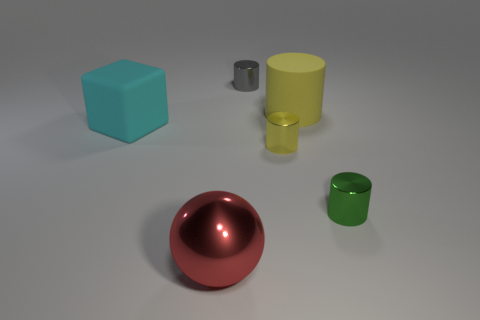What is the material of the other cylinder that is the same color as the big cylinder?
Provide a short and direct response. Metal. There is a big thing in front of the rubber thing in front of the big yellow cylinder; is there a big shiny thing that is behind it?
Ensure brevity in your answer.  No. What number of other things are there of the same material as the big yellow thing
Provide a short and direct response. 1. How many brown matte cubes are there?
Offer a terse response. 0. How many things are either large cyan matte objects or cylinders that are in front of the large matte cylinder?
Your answer should be compact. 3. Are there any other things that have the same shape as the large red metal thing?
Offer a very short reply. No. There is a thing that is left of the red shiny object; does it have the same size as the yellow shiny thing?
Give a very brief answer. No. How many matte things are either yellow balls or cubes?
Make the answer very short. 1. What size is the object on the right side of the big yellow cylinder?
Offer a terse response. Small. Do the gray thing and the yellow metal thing have the same shape?
Give a very brief answer. Yes. 